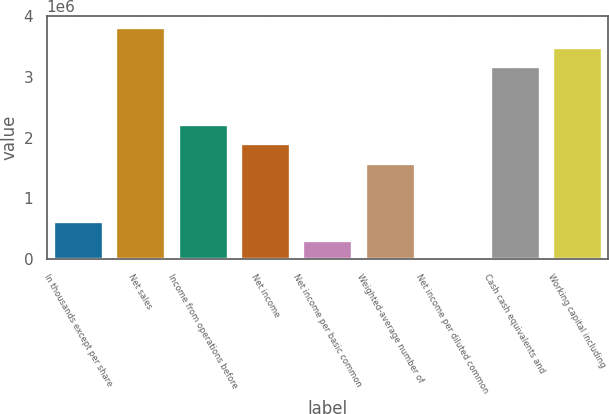Convert chart. <chart><loc_0><loc_0><loc_500><loc_500><bar_chart><fcel>In thousands except per share<fcel>Net sales<fcel>Income from operations before<fcel>Net income<fcel>Net income per basic common<fcel>Weighted-average number of<fcel>Net income per diluted common<fcel>Cash cash equivalents and<fcel>Working capital including<nl><fcel>636324<fcel>3.81792e+06<fcel>2.22712e+06<fcel>1.90896e+06<fcel>318164<fcel>1.5908e+06<fcel>5.19<fcel>3.1816e+06<fcel>3.49976e+06<nl></chart> 